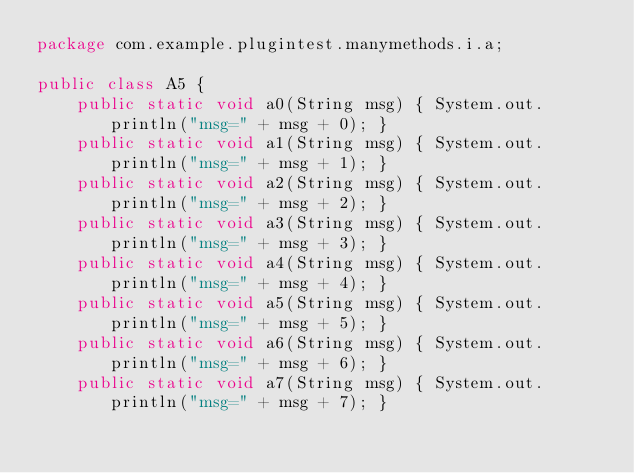<code> <loc_0><loc_0><loc_500><loc_500><_Java_>package com.example.plugintest.manymethods.i.a;

public class A5 {
    public static void a0(String msg) { System.out.println("msg=" + msg + 0); }
    public static void a1(String msg) { System.out.println("msg=" + msg + 1); }
    public static void a2(String msg) { System.out.println("msg=" + msg + 2); }
    public static void a3(String msg) { System.out.println("msg=" + msg + 3); }
    public static void a4(String msg) { System.out.println("msg=" + msg + 4); }
    public static void a5(String msg) { System.out.println("msg=" + msg + 5); }
    public static void a6(String msg) { System.out.println("msg=" + msg + 6); }
    public static void a7(String msg) { System.out.println("msg=" + msg + 7); }</code> 